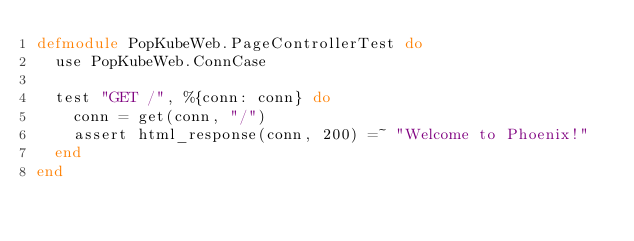<code> <loc_0><loc_0><loc_500><loc_500><_Elixir_>defmodule PopKubeWeb.PageControllerTest do
  use PopKubeWeb.ConnCase

  test "GET /", %{conn: conn} do
    conn = get(conn, "/")
    assert html_response(conn, 200) =~ "Welcome to Phoenix!"
  end
end
</code> 